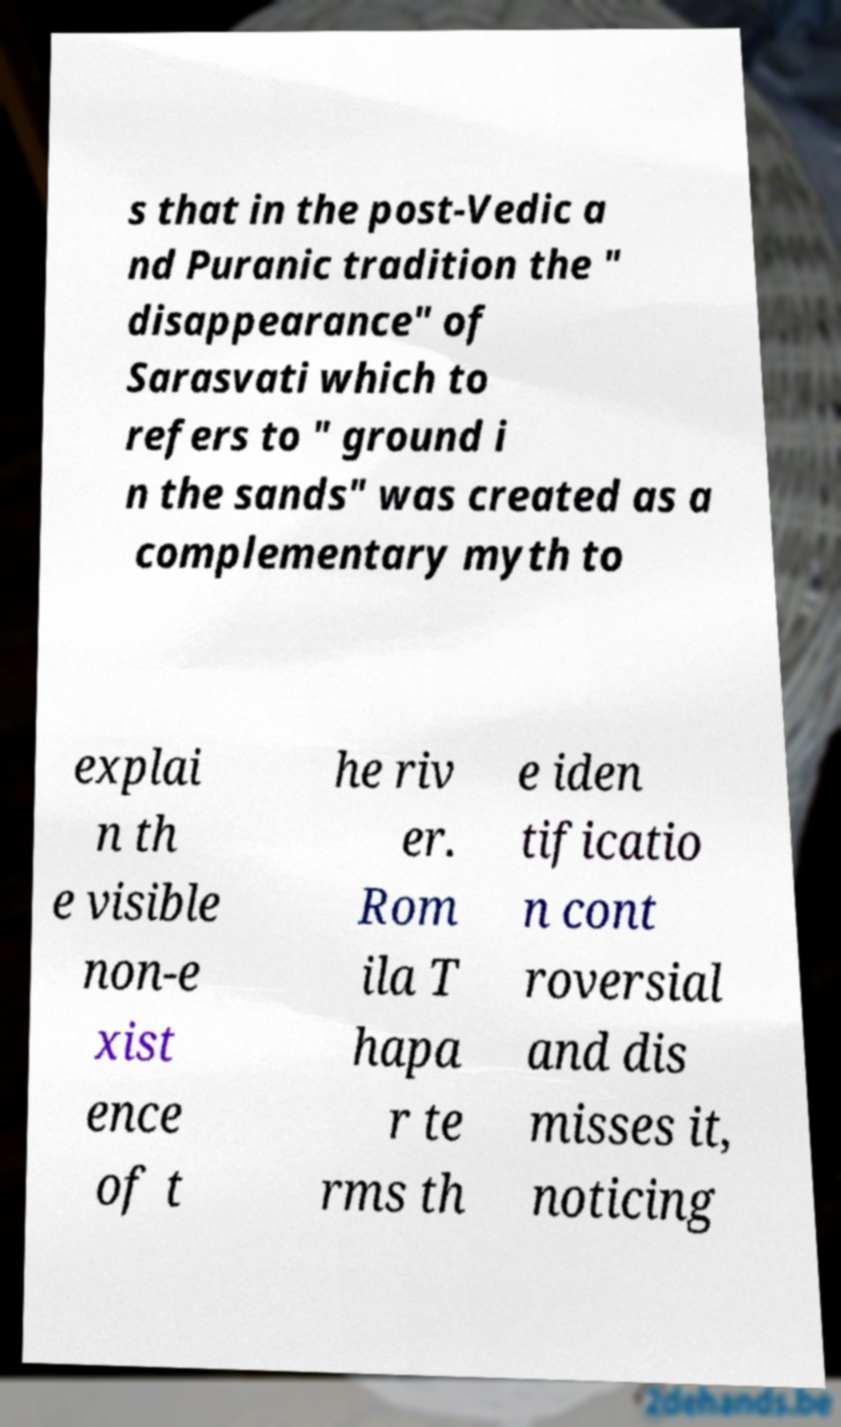I need the written content from this picture converted into text. Can you do that? s that in the post-Vedic a nd Puranic tradition the " disappearance" of Sarasvati which to refers to " ground i n the sands" was created as a complementary myth to explai n th e visible non-e xist ence of t he riv er. Rom ila T hapa r te rms th e iden tificatio n cont roversial and dis misses it, noticing 